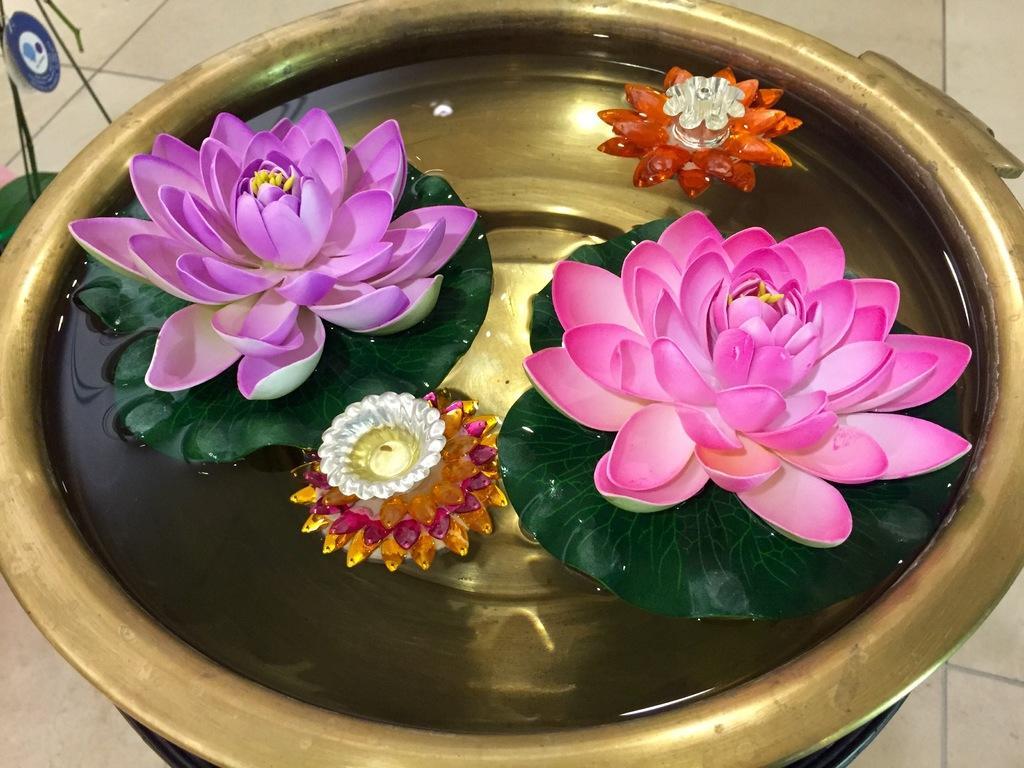Please provide a concise description of this image. In this image there is a metal bowl. In the bowl there is water. In the water there are plastic flowers and diyas. 